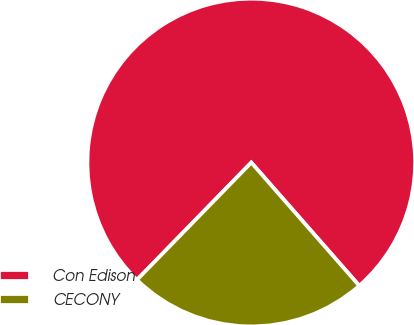Convert chart to OTSL. <chart><loc_0><loc_0><loc_500><loc_500><pie_chart><fcel>Con Edison<fcel>CECONY<nl><fcel>76.25%<fcel>23.75%<nl></chart> 